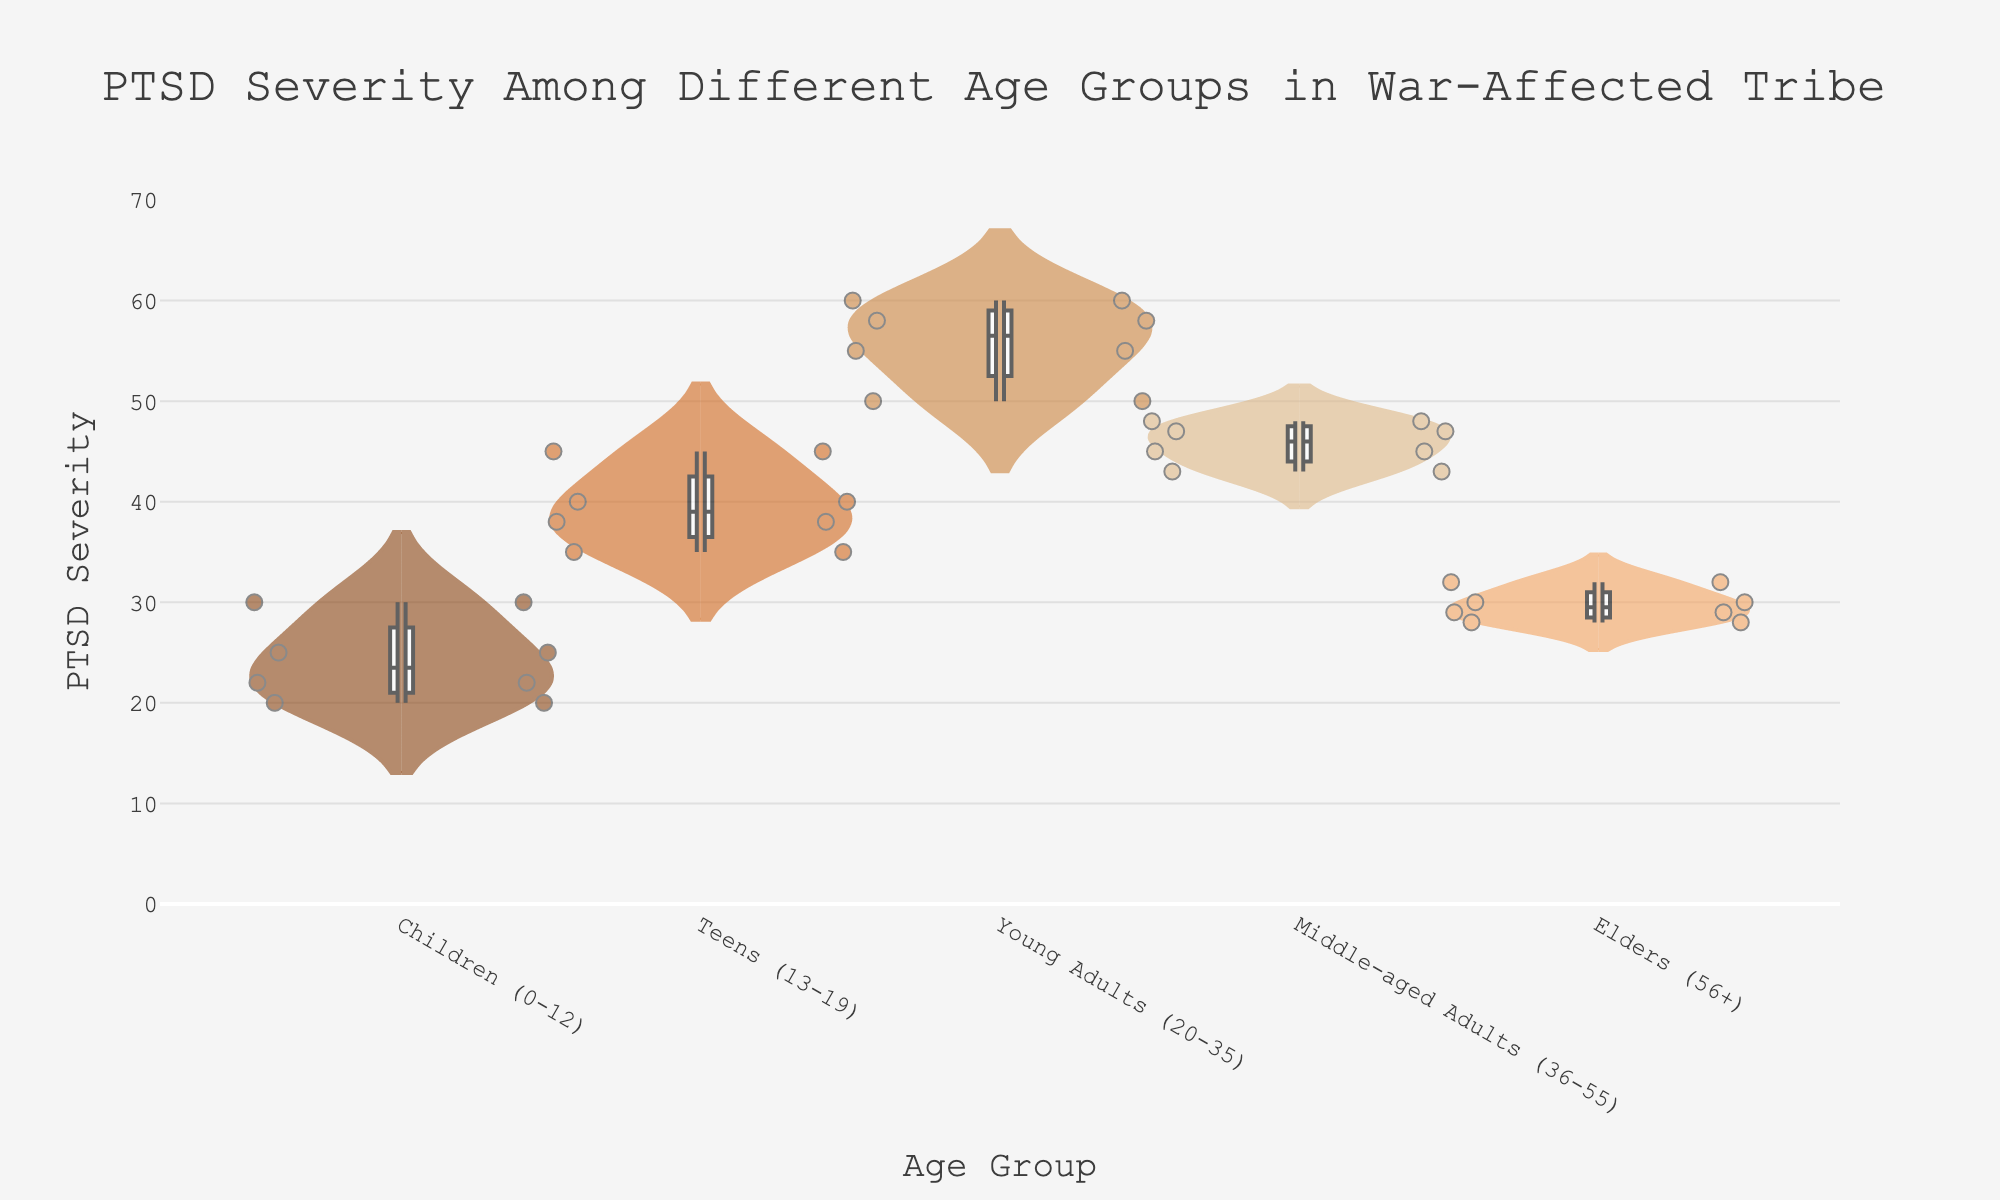What is the title of the figure? The title is located at the top and reads "PTSD Severity Among Different Age Groups in War-Affected Tribe".
Answer: PTSD Severity Among Different Age Groups in War-Affected Tribe Which age group has the highest median PTSD severity? To find the median PTSD severity for each age group, look at the box in each violin plot. The highest median severity is observed in the "Young Adults (20-35)" group.
Answer: Young Adults (20-35) How many data points are represented for the "Children (0-12)" age group? Each dot inside the violin plot represents a data point. Count the number of dots for "Children (0-12)", which are four.
Answer: 4 What is the range of PTSD severity for "Elders (56+)"? The range is determined by the minimum and maximum values. For "Elders (56+)", it ranges from 28 to 32.
Answer: 28-32 Compare the modal PTSD severity level between "Teens (13-19)" and "Middle-aged Adults (36-55)". Which group has a higher mode? The mode is the most frequent value in the dataset. For "Teens (13-19)" it appears around 40-45, while for "Middle-aged Adults (36-55)" it clusters around 45-48. "Teens (13-19)" has a higher mode.
Answer: Teens (13-19) Which age group shows the most variability in PTSD severity? Variability is shown by the spread of the violin plot. "Young Adults (20-35)" has a wider spread from 50 to 60, indicating more variability.
Answer: Young Adults (20-35) Calculate the interquartile range (IQR) for the "Middle-aged Adults (36-55)" group. The IQR is the range between the first quartile (Q1) and the third quartile (Q3). For "Middle-aged Adults (36-55)", Q1 is around 43 and Q3 is around 48, so IQR = 48 - 43 = 5.
Answer: 5 Which age group has the least severe PTSD overall? Look for the group with the lowest range and median. "Children (0-12)" shows the least severe PTSD with values between 20 and 30 and a median around 25.
Answer: Children (0-12) What unique insight can be gathered about PTSD severity specifically from the violin plot? Violin plots help visualize the distribution shape, spread, and density. We can see some age groups have more centralized densities like "Children (0-12)", while others have a wider spread, like "Young Adults (20-35)". This helps understand the trauma impact variability across different age groups.
Answer: Insights on distribution density and spread 